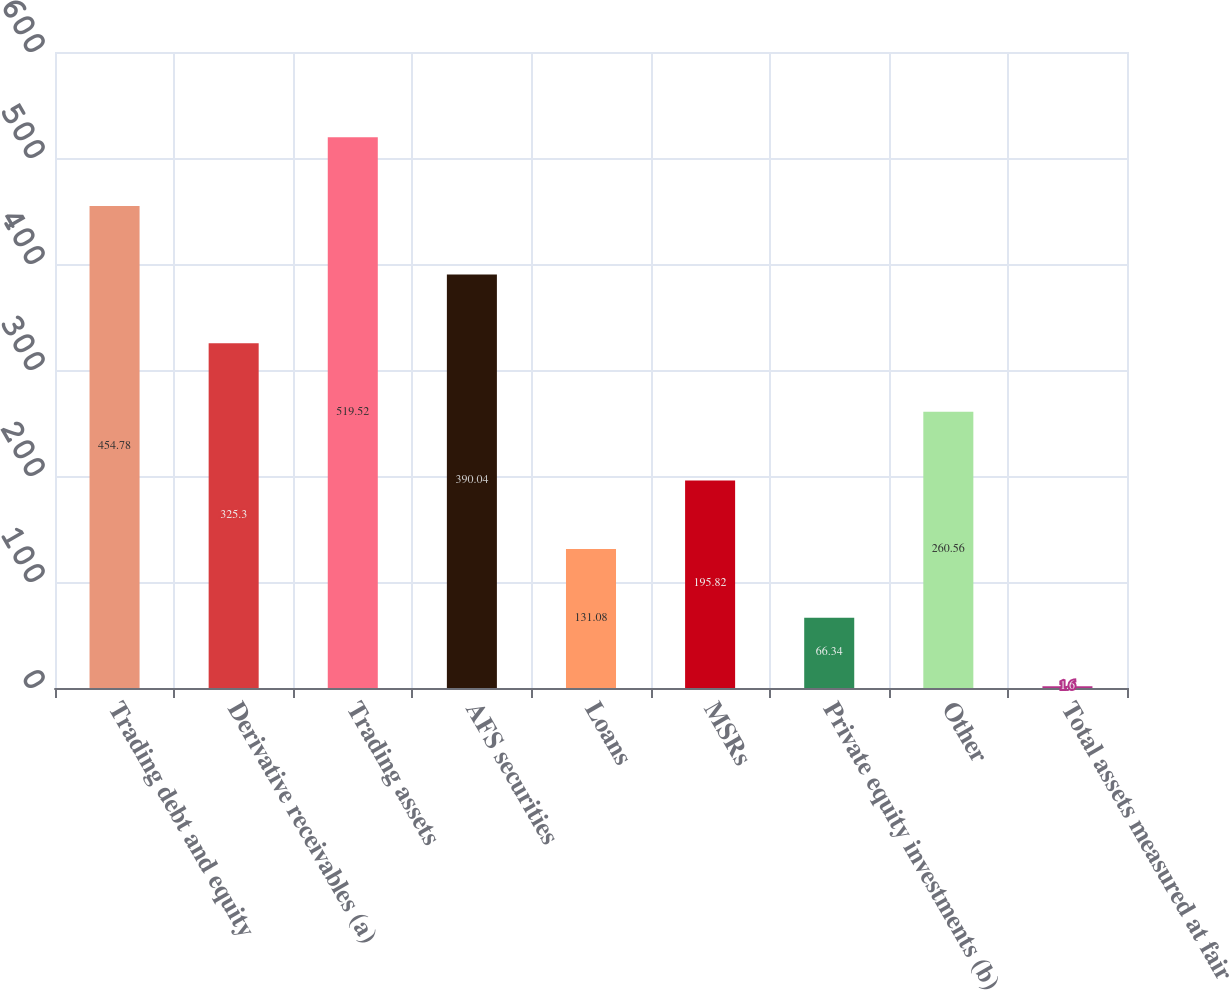Convert chart to OTSL. <chart><loc_0><loc_0><loc_500><loc_500><bar_chart><fcel>Trading debt and equity<fcel>Derivative receivables (a)<fcel>Trading assets<fcel>AFS securities<fcel>Loans<fcel>MSRs<fcel>Private equity investments (b)<fcel>Other<fcel>Total assets measured at fair<nl><fcel>454.78<fcel>325.3<fcel>519.52<fcel>390.04<fcel>131.08<fcel>195.82<fcel>66.34<fcel>260.56<fcel>1.6<nl></chart> 